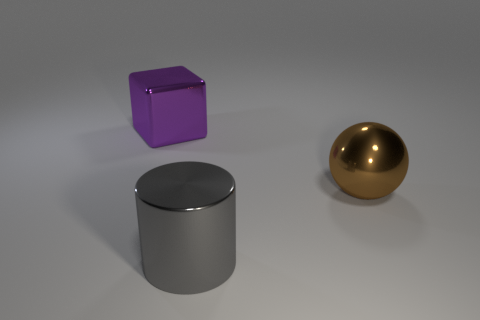Add 2 large metal things. How many objects exist? 5 Subtract all cubes. How many objects are left? 2 Add 3 shiny things. How many shiny things are left? 6 Add 3 metallic balls. How many metallic balls exist? 4 Subtract 0 blue blocks. How many objects are left? 3 Subtract all large green things. Subtract all purple metallic objects. How many objects are left? 2 